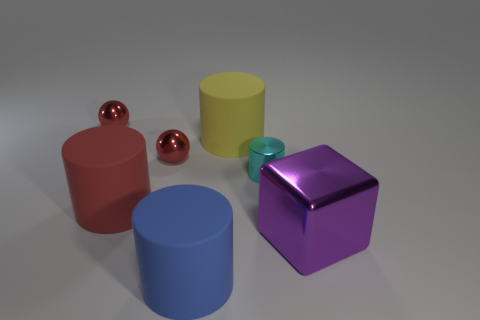Is the number of large purple shiny objects right of the large yellow object greater than the number of large yellow cylinders that are in front of the red matte cylinder?
Make the answer very short. Yes. What number of other metallic blocks have the same color as the large block?
Your answer should be compact. 0. What size is the red cylinder that is the same material as the yellow cylinder?
Your answer should be very brief. Large. How many objects are small shiny spheres behind the yellow rubber thing or large matte things?
Your answer should be compact. 4. There is a cylinder on the left side of the blue thing; is it the same color as the shiny block?
Your answer should be very brief. No. There is a blue object that is the same shape as the small cyan object; what is its size?
Your answer should be very brief. Large. What is the color of the small shiny object that is to the right of the large cylinder that is in front of the large purple metallic cube that is in front of the big yellow cylinder?
Offer a very short reply. Cyan. Are the big yellow object and the big blue cylinder made of the same material?
Provide a succinct answer. Yes. Are there any big purple cubes that are to the right of the big rubber cylinder that is right of the big object in front of the large purple cube?
Ensure brevity in your answer.  Yes. Does the large shiny cube have the same color as the metallic cylinder?
Provide a succinct answer. No. 